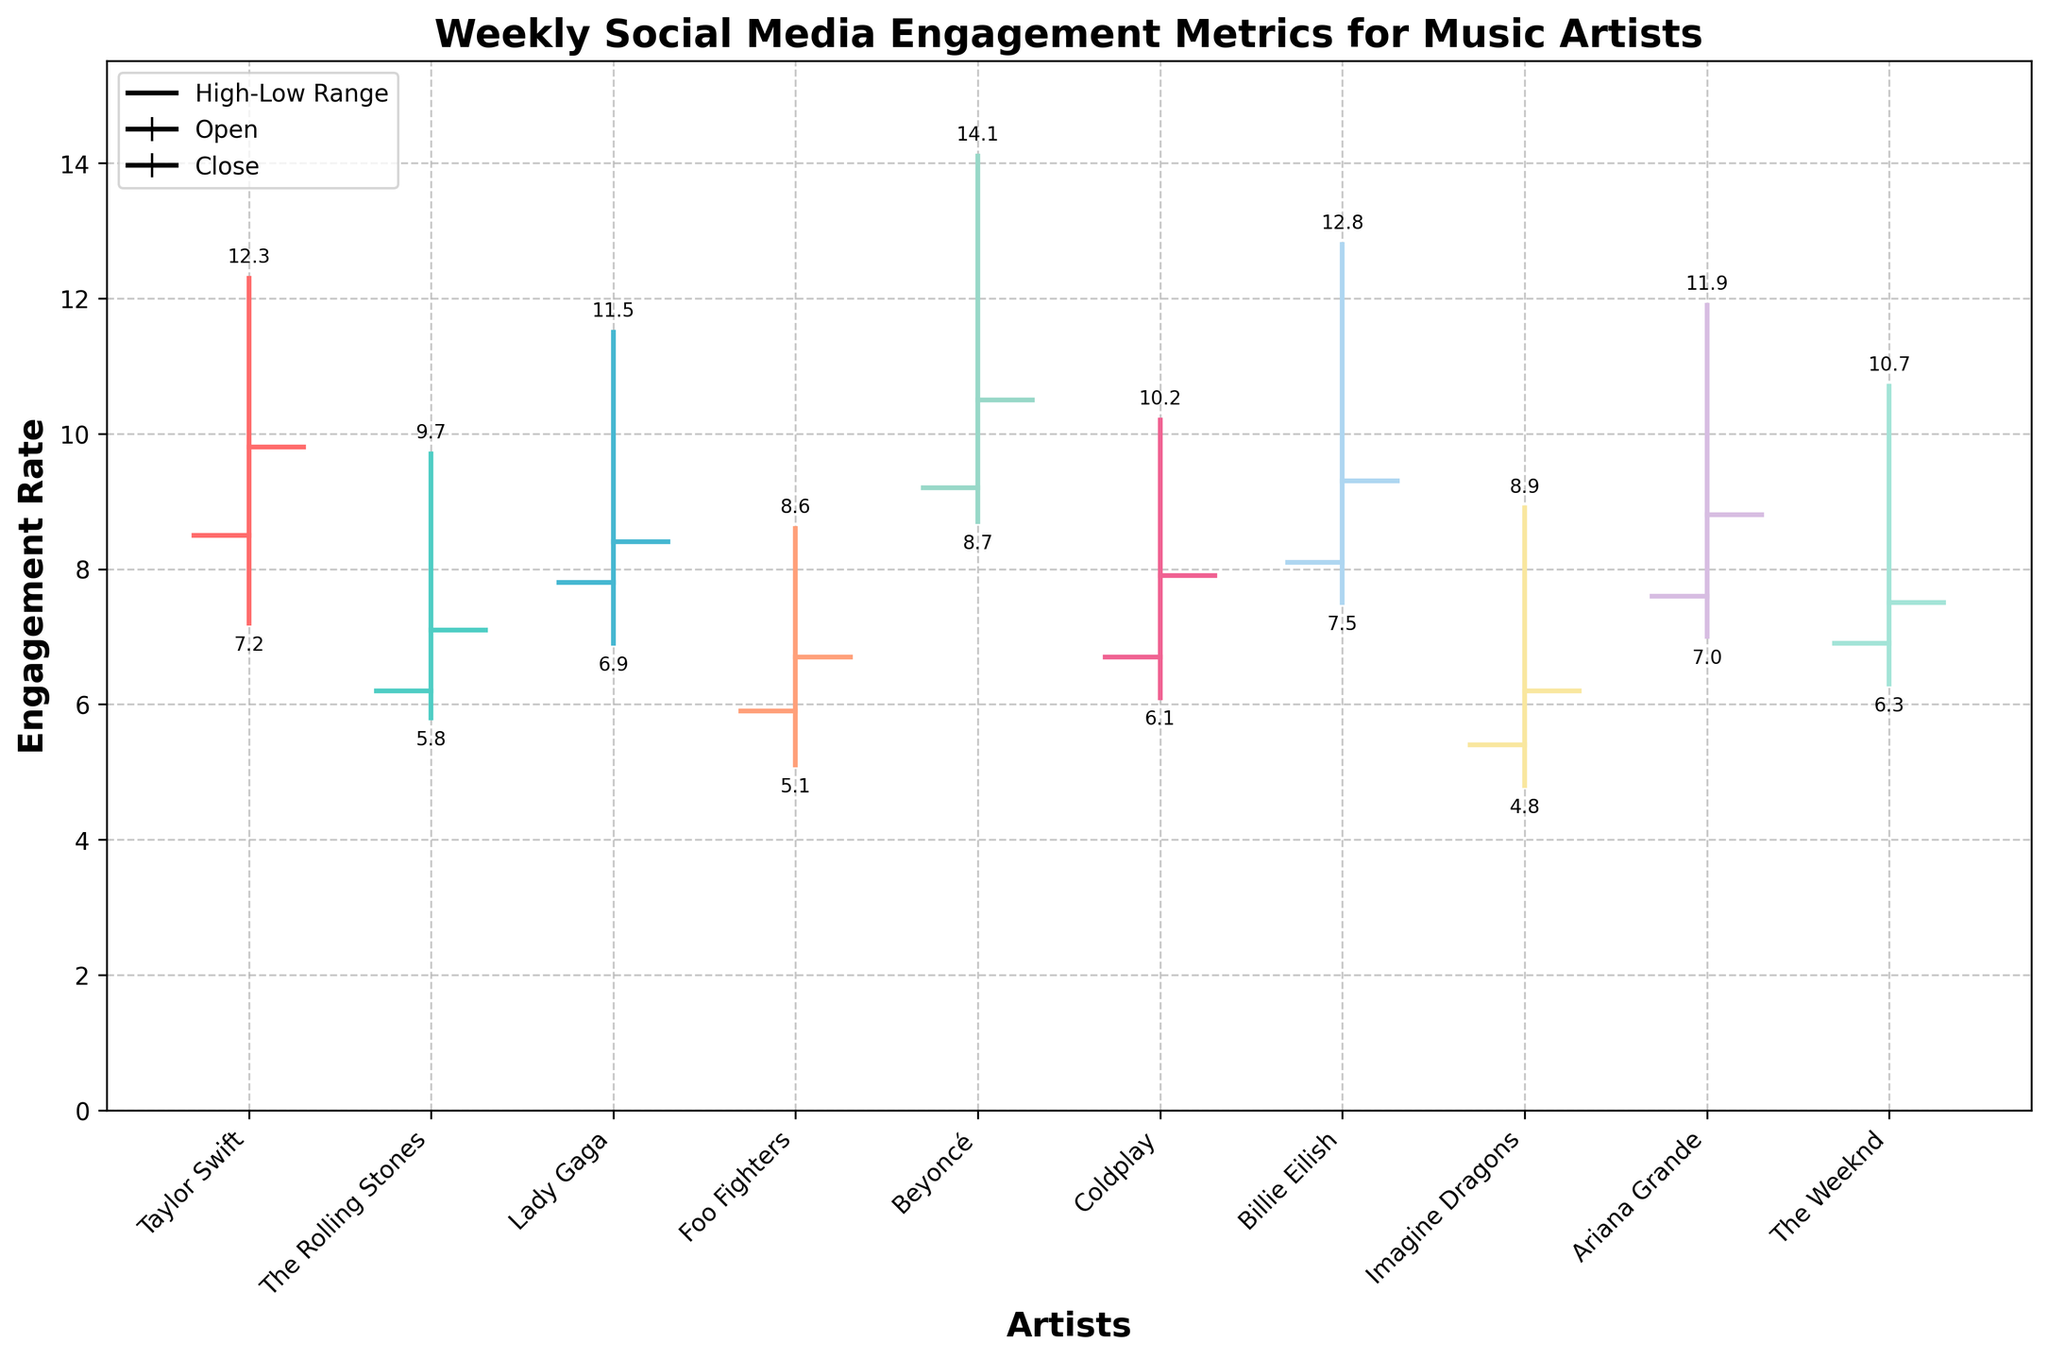What's the title of the figure? The title of the figure is displayed at the top and provides an overall description of what the chart represents.
Answer: Weekly Social Media Engagement Metrics for Music Artists What's the artist with the highest maximum engagement rate? You need to look at the data points that represent the highest engagement rates (the top points of the bars) and identify the artist corresponding to the highest of these points.
Answer: Beyoncé Which artist had the lowest minimum engagement rate and what was it? To find the lowest minimum engagement rate, identify the lowest points on the chart and see which artist corresponds to that point.
Answer: Imagine Dragons, 4.8 For Taylor Swift, what was the range of engagement rates during the week? The range is calculated by subtracting the minimum engagement rate from the maximum engagement rate for Taylor Swift. The maximum rate was 12.3 and the minimum was 7.2.
Answer: 5.1 Compare the initial engagement rate of Foo Fighters and The Weeknd. Which one is higher? Compare the initial engagement rates of both artists by looking at the left markers of their respective bars. Foo Fighters had an initial rate of 5.9, whereas The Weeknd had 6.9.
Answer: The Weeknd Which artist had the smallest difference between their initial and final engagement rates, and what was the difference? To find this, subtract the initial engagement rate from the final engagement rate for each artist. The smallest absolute difference is what we're looking for.
Answer: Lady Gaga, 0.6 What is the average final engagement rate of artists displayed in the figure? To find the average final engagement rate, sum up all the final engagement rates and divide by the number of artists. The sum is 84.2 and there are 10 artists.
Answer: 8.42 Which artist had an increase in engagement from the initial to the final rate, and what was the amount of the increase? Look for artists where their final rate is higher than their initial, then calculate the difference. For example, Beyoncé's initial rate was 9.2 and final rate was 10.5, an increase of 1.3.
Answer: Beyoncé, 1.3 How many artists have a final engagement rate higher than 9? Count the data points representing final engagement rates greater than 9 by evaluating each artist’s final rate. Taylor Swift, Beyoncé, and Billie Eilish meet the criteria.
Answer: 3 